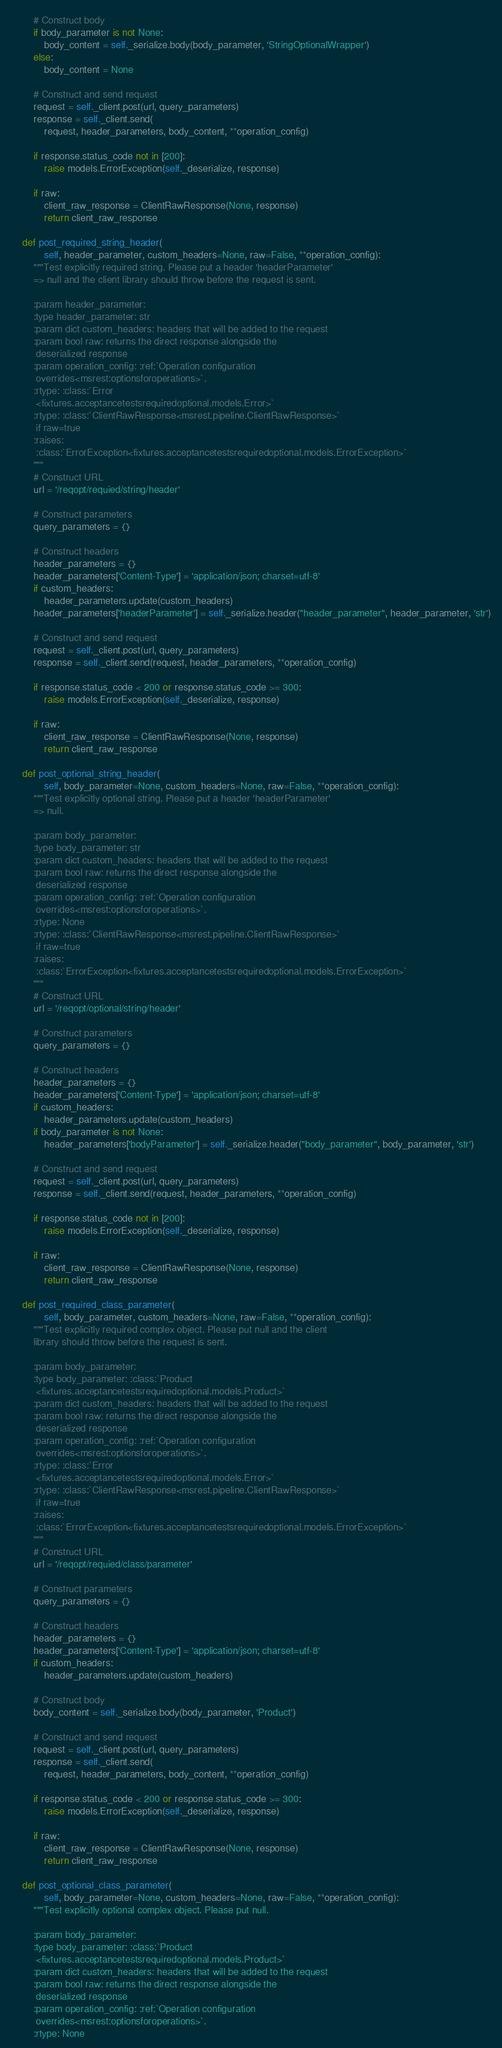<code> <loc_0><loc_0><loc_500><loc_500><_Python_>        # Construct body
        if body_parameter is not None:
            body_content = self._serialize.body(body_parameter, 'StringOptionalWrapper')
        else:
            body_content = None

        # Construct and send request
        request = self._client.post(url, query_parameters)
        response = self._client.send(
            request, header_parameters, body_content, **operation_config)

        if response.status_code not in [200]:
            raise models.ErrorException(self._deserialize, response)

        if raw:
            client_raw_response = ClientRawResponse(None, response)
            return client_raw_response

    def post_required_string_header(
            self, header_parameter, custom_headers=None, raw=False, **operation_config):
        """Test explicitly required string. Please put a header 'headerParameter'
        => null and the client library should throw before the request is sent.

        :param header_parameter:
        :type header_parameter: str
        :param dict custom_headers: headers that will be added to the request
        :param bool raw: returns the direct response alongside the
         deserialized response
        :param operation_config: :ref:`Operation configuration
         overrides<msrest:optionsforoperations>`.
        :rtype: :class:`Error
         <fixtures.acceptancetestsrequiredoptional.models.Error>`
        :rtype: :class:`ClientRawResponse<msrest.pipeline.ClientRawResponse>`
         if raw=true
        :raises:
         :class:`ErrorException<fixtures.acceptancetestsrequiredoptional.models.ErrorException>`
        """
        # Construct URL
        url = '/reqopt/requied/string/header'

        # Construct parameters
        query_parameters = {}

        # Construct headers
        header_parameters = {}
        header_parameters['Content-Type'] = 'application/json; charset=utf-8'
        if custom_headers:
            header_parameters.update(custom_headers)
        header_parameters['headerParameter'] = self._serialize.header("header_parameter", header_parameter, 'str')

        # Construct and send request
        request = self._client.post(url, query_parameters)
        response = self._client.send(request, header_parameters, **operation_config)

        if response.status_code < 200 or response.status_code >= 300:
            raise models.ErrorException(self._deserialize, response)

        if raw:
            client_raw_response = ClientRawResponse(None, response)
            return client_raw_response

    def post_optional_string_header(
            self, body_parameter=None, custom_headers=None, raw=False, **operation_config):
        """Test explicitly optional string. Please put a header 'headerParameter'
        => null.

        :param body_parameter:
        :type body_parameter: str
        :param dict custom_headers: headers that will be added to the request
        :param bool raw: returns the direct response alongside the
         deserialized response
        :param operation_config: :ref:`Operation configuration
         overrides<msrest:optionsforoperations>`.
        :rtype: None
        :rtype: :class:`ClientRawResponse<msrest.pipeline.ClientRawResponse>`
         if raw=true
        :raises:
         :class:`ErrorException<fixtures.acceptancetestsrequiredoptional.models.ErrorException>`
        """
        # Construct URL
        url = '/reqopt/optional/string/header'

        # Construct parameters
        query_parameters = {}

        # Construct headers
        header_parameters = {}
        header_parameters['Content-Type'] = 'application/json; charset=utf-8'
        if custom_headers:
            header_parameters.update(custom_headers)
        if body_parameter is not None:
            header_parameters['bodyParameter'] = self._serialize.header("body_parameter", body_parameter, 'str')

        # Construct and send request
        request = self._client.post(url, query_parameters)
        response = self._client.send(request, header_parameters, **operation_config)

        if response.status_code not in [200]:
            raise models.ErrorException(self._deserialize, response)

        if raw:
            client_raw_response = ClientRawResponse(None, response)
            return client_raw_response

    def post_required_class_parameter(
            self, body_parameter, custom_headers=None, raw=False, **operation_config):
        """Test explicitly required complex object. Please put null and the client
        library should throw before the request is sent.

        :param body_parameter:
        :type body_parameter: :class:`Product
         <fixtures.acceptancetestsrequiredoptional.models.Product>`
        :param dict custom_headers: headers that will be added to the request
        :param bool raw: returns the direct response alongside the
         deserialized response
        :param operation_config: :ref:`Operation configuration
         overrides<msrest:optionsforoperations>`.
        :rtype: :class:`Error
         <fixtures.acceptancetestsrequiredoptional.models.Error>`
        :rtype: :class:`ClientRawResponse<msrest.pipeline.ClientRawResponse>`
         if raw=true
        :raises:
         :class:`ErrorException<fixtures.acceptancetestsrequiredoptional.models.ErrorException>`
        """
        # Construct URL
        url = '/reqopt/requied/class/parameter'

        # Construct parameters
        query_parameters = {}

        # Construct headers
        header_parameters = {}
        header_parameters['Content-Type'] = 'application/json; charset=utf-8'
        if custom_headers:
            header_parameters.update(custom_headers)

        # Construct body
        body_content = self._serialize.body(body_parameter, 'Product')

        # Construct and send request
        request = self._client.post(url, query_parameters)
        response = self._client.send(
            request, header_parameters, body_content, **operation_config)

        if response.status_code < 200 or response.status_code >= 300:
            raise models.ErrorException(self._deserialize, response)

        if raw:
            client_raw_response = ClientRawResponse(None, response)
            return client_raw_response

    def post_optional_class_parameter(
            self, body_parameter=None, custom_headers=None, raw=False, **operation_config):
        """Test explicitly optional complex object. Please put null.

        :param body_parameter:
        :type body_parameter: :class:`Product
         <fixtures.acceptancetestsrequiredoptional.models.Product>`
        :param dict custom_headers: headers that will be added to the request
        :param bool raw: returns the direct response alongside the
         deserialized response
        :param operation_config: :ref:`Operation configuration
         overrides<msrest:optionsforoperations>`.
        :rtype: None</code> 